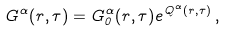<formula> <loc_0><loc_0><loc_500><loc_500>G ^ { \alpha } ( { r } , \tau ) = G ^ { \alpha } _ { 0 } ( { r } , \tau ) e ^ { Q ^ { \alpha } ( { r } , \tau ) } \, ,</formula> 